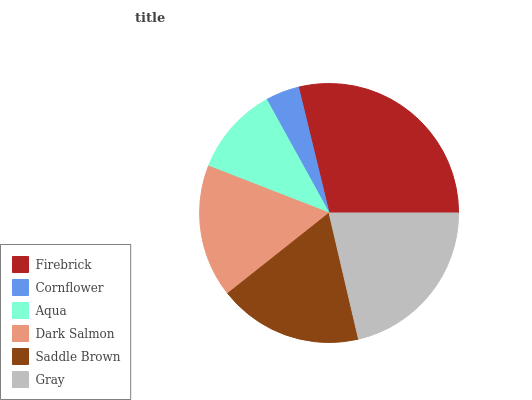Is Cornflower the minimum?
Answer yes or no. Yes. Is Firebrick the maximum?
Answer yes or no. Yes. Is Aqua the minimum?
Answer yes or no. No. Is Aqua the maximum?
Answer yes or no. No. Is Aqua greater than Cornflower?
Answer yes or no. Yes. Is Cornflower less than Aqua?
Answer yes or no. Yes. Is Cornflower greater than Aqua?
Answer yes or no. No. Is Aqua less than Cornflower?
Answer yes or no. No. Is Saddle Brown the high median?
Answer yes or no. Yes. Is Dark Salmon the low median?
Answer yes or no. Yes. Is Aqua the high median?
Answer yes or no. No. Is Cornflower the low median?
Answer yes or no. No. 